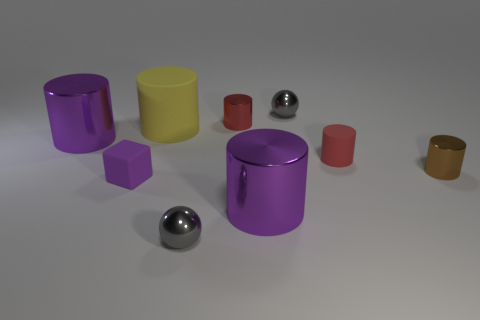What is the shape of the purple object that is made of the same material as the yellow cylinder?
Your response must be concise. Cube. What number of other objects are the same shape as the large yellow rubber object?
Your response must be concise. 5. There is a large yellow cylinder; how many yellow cylinders are on the right side of it?
Offer a terse response. 0. Does the red cylinder that is on the left side of the small red matte cylinder have the same size as the gray metallic thing in front of the yellow cylinder?
Provide a succinct answer. Yes. How many other things are the same size as the red metal object?
Give a very brief answer. 5. There is a tiny gray ball that is behind the purple shiny object on the right side of the big metal object that is left of the large yellow cylinder; what is its material?
Keep it short and to the point. Metal. Do the brown metal object and the matte object that is behind the small red matte cylinder have the same size?
Your answer should be compact. No. There is a shiny object that is both behind the small brown cylinder and on the left side of the red shiny thing; what is its size?
Provide a succinct answer. Large. Is there a cylinder that has the same color as the matte cube?
Offer a terse response. Yes. The small cylinder on the left side of the big metallic thing in front of the purple cube is what color?
Give a very brief answer. Red. 